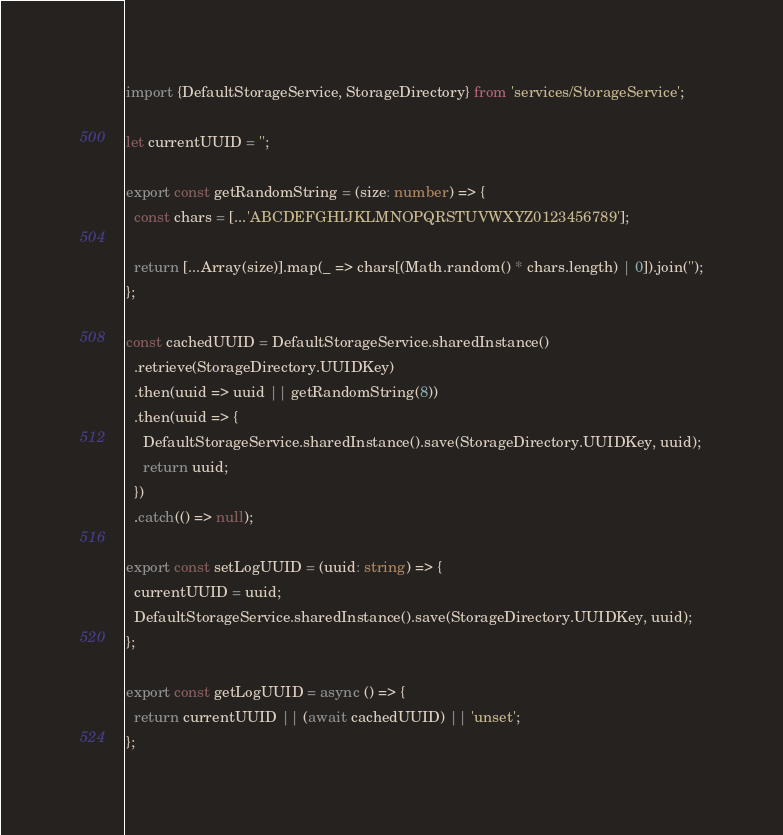<code> <loc_0><loc_0><loc_500><loc_500><_TypeScript_>import {DefaultStorageService, StorageDirectory} from 'services/StorageService';

let currentUUID = '';

export const getRandomString = (size: number) => {
  const chars = [...'ABCDEFGHIJKLMNOPQRSTUVWXYZ0123456789'];

  return [...Array(size)].map(_ => chars[(Math.random() * chars.length) | 0]).join('');
};

const cachedUUID = DefaultStorageService.sharedInstance()
  .retrieve(StorageDirectory.UUIDKey)
  .then(uuid => uuid || getRandomString(8))
  .then(uuid => {
    DefaultStorageService.sharedInstance().save(StorageDirectory.UUIDKey, uuid);
    return uuid;
  })
  .catch(() => null);

export const setLogUUID = (uuid: string) => {
  currentUUID = uuid;
  DefaultStorageService.sharedInstance().save(StorageDirectory.UUIDKey, uuid);
};

export const getLogUUID = async () => {
  return currentUUID || (await cachedUUID) || 'unset';
};
</code> 